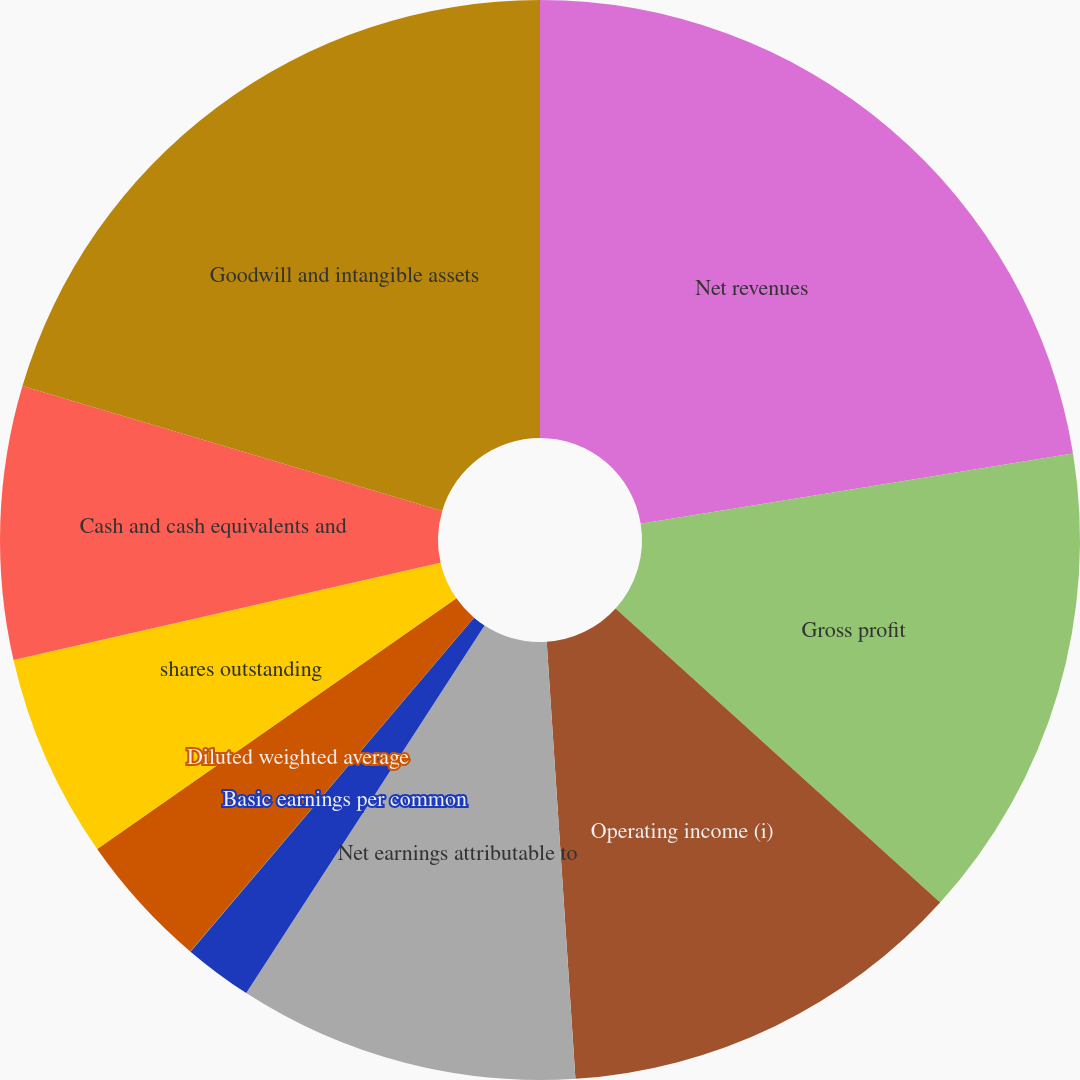Convert chart. <chart><loc_0><loc_0><loc_500><loc_500><pie_chart><fcel>Net revenues<fcel>Gross profit<fcel>Operating income (i)<fcel>Net earnings attributable to<fcel>Basic earnings per common<fcel>Diluted earnings per common<fcel>Diluted weighted average<fcel>shares outstanding<fcel>Cash and cash equivalents and<fcel>Goodwill and intangible assets<nl><fcel>22.44%<fcel>14.28%<fcel>12.24%<fcel>10.2%<fcel>2.05%<fcel>0.01%<fcel>4.09%<fcel>6.13%<fcel>8.17%<fcel>20.4%<nl></chart> 